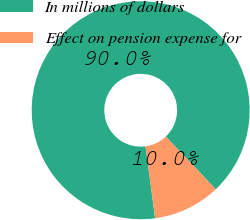<chart> <loc_0><loc_0><loc_500><loc_500><pie_chart><fcel>In millions of dollars<fcel>Effect on pension expense for<nl><fcel>90.03%<fcel>9.97%<nl></chart> 